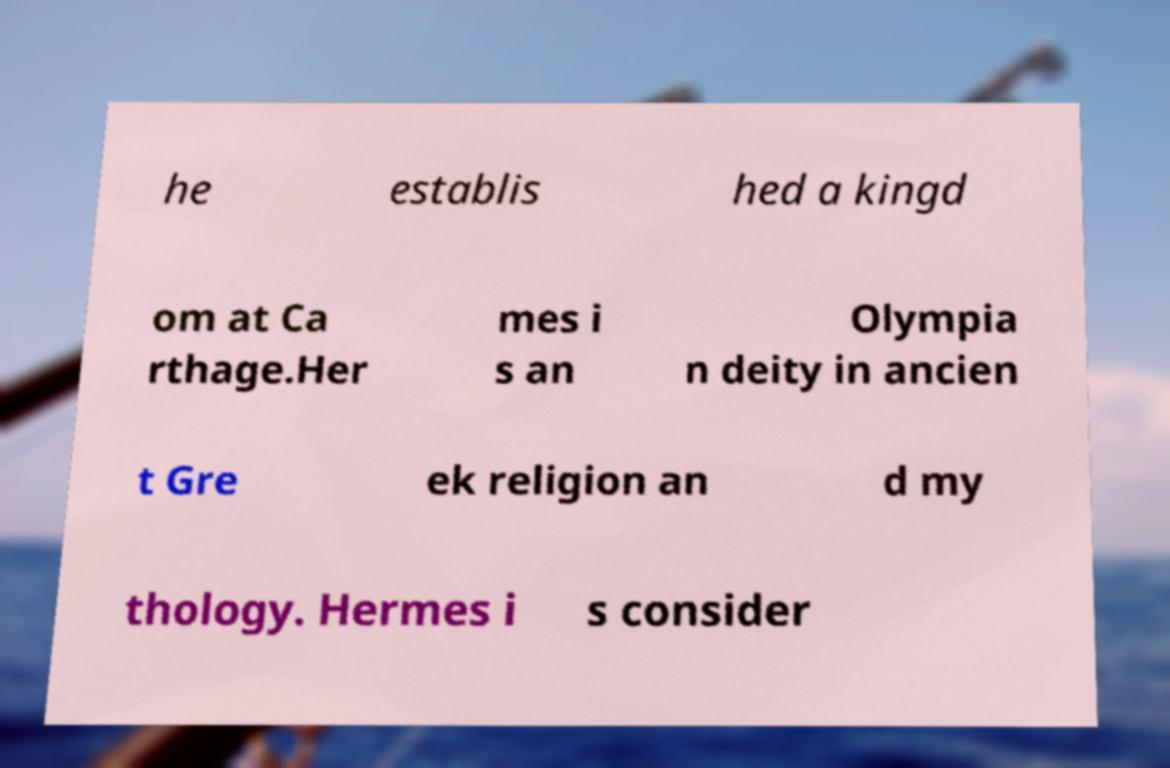Can you accurately transcribe the text from the provided image for me? he establis hed a kingd om at Ca rthage.Her mes i s an Olympia n deity in ancien t Gre ek religion an d my thology. Hermes i s consider 